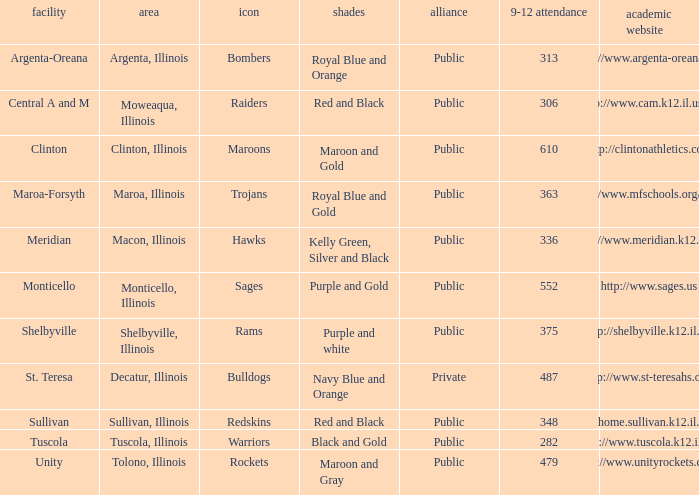What's the website of the school in Macon, Illinois? Http://www.meridian.k12.il.us/. 